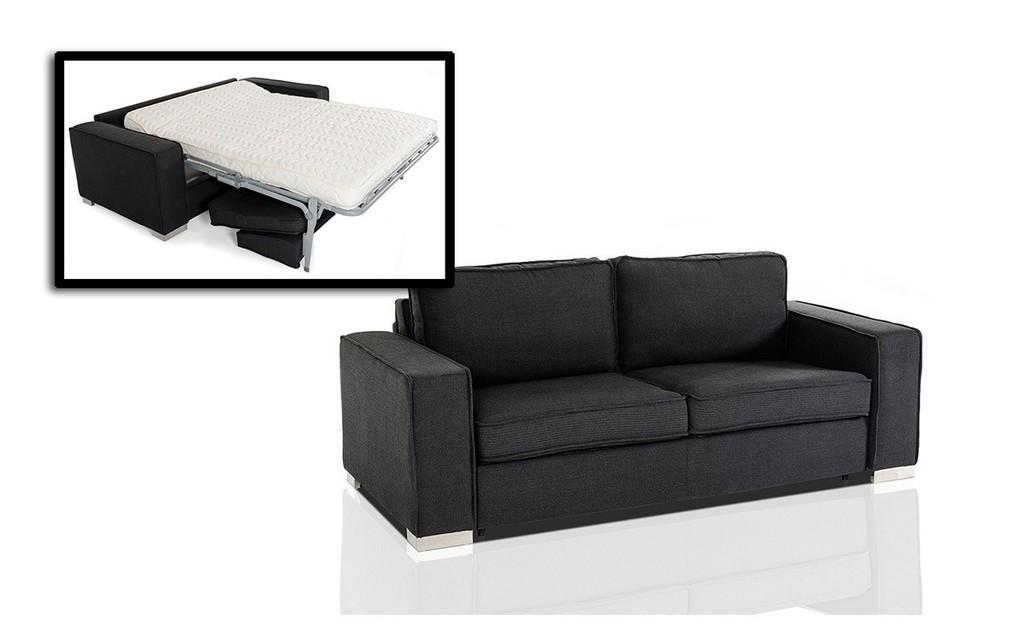In one or two sentences, can you explain what this image depicts? In this picture we can see a black colour sofa. Here we can see a screen where we can see a sofa and a bed on it which is in white colour. 